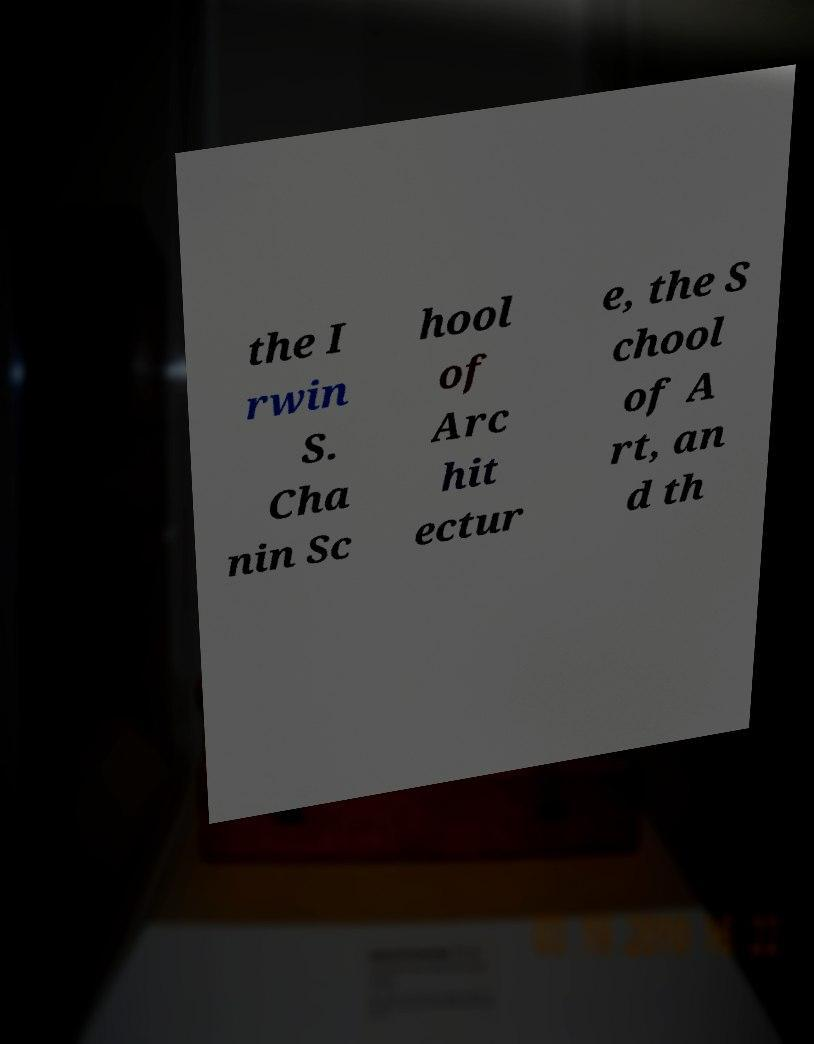There's text embedded in this image that I need extracted. Can you transcribe it verbatim? the I rwin S. Cha nin Sc hool of Arc hit ectur e, the S chool of A rt, an d th 